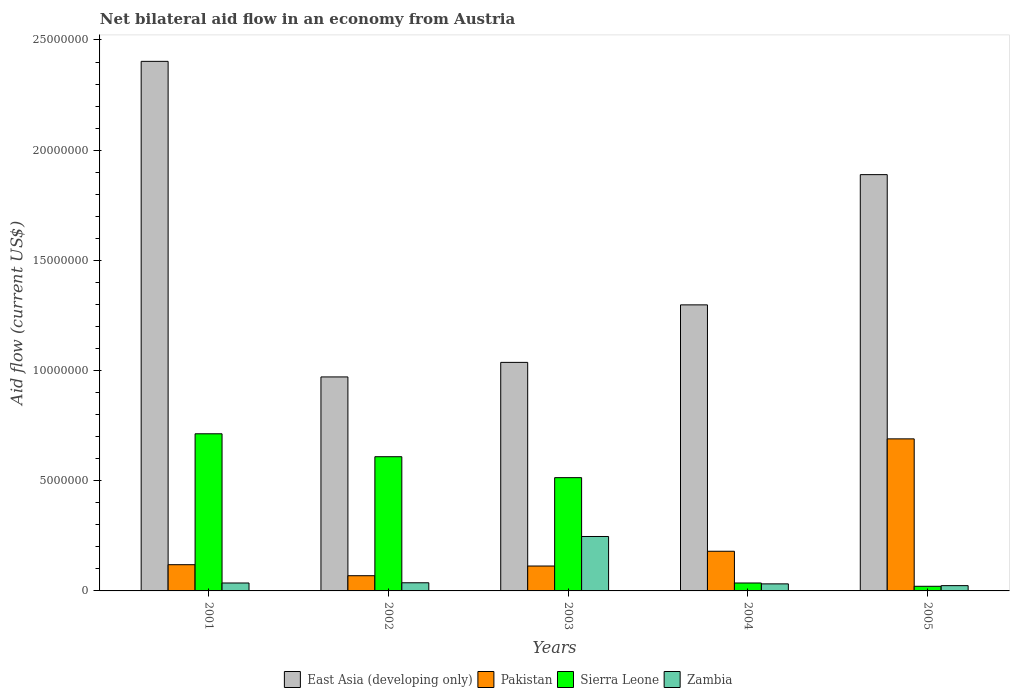How many different coloured bars are there?
Provide a short and direct response. 4. How many groups of bars are there?
Give a very brief answer. 5. Are the number of bars per tick equal to the number of legend labels?
Your answer should be compact. Yes. What is the label of the 5th group of bars from the left?
Ensure brevity in your answer.  2005. What is the net bilateral aid flow in Sierra Leone in 2004?
Make the answer very short. 3.60e+05. Across all years, what is the maximum net bilateral aid flow in East Asia (developing only)?
Keep it short and to the point. 2.40e+07. Across all years, what is the minimum net bilateral aid flow in Pakistan?
Provide a succinct answer. 6.90e+05. What is the total net bilateral aid flow in Pakistan in the graph?
Keep it short and to the point. 1.17e+07. What is the difference between the net bilateral aid flow in Zambia in 2004 and that in 2005?
Offer a very short reply. 8.00e+04. What is the difference between the net bilateral aid flow in Zambia in 2005 and the net bilateral aid flow in East Asia (developing only) in 2001?
Make the answer very short. -2.38e+07. What is the average net bilateral aid flow in Pakistan per year?
Ensure brevity in your answer.  2.34e+06. In the year 2004, what is the difference between the net bilateral aid flow in Sierra Leone and net bilateral aid flow in Zambia?
Offer a very short reply. 4.00e+04. In how many years, is the net bilateral aid flow in Sierra Leone greater than 9000000 US$?
Your answer should be very brief. 0. What is the ratio of the net bilateral aid flow in East Asia (developing only) in 2001 to that in 2005?
Give a very brief answer. 1.27. Is the difference between the net bilateral aid flow in Sierra Leone in 2004 and 2005 greater than the difference between the net bilateral aid flow in Zambia in 2004 and 2005?
Offer a terse response. Yes. What is the difference between the highest and the second highest net bilateral aid flow in Pakistan?
Your answer should be very brief. 5.10e+06. What is the difference between the highest and the lowest net bilateral aid flow in East Asia (developing only)?
Ensure brevity in your answer.  1.43e+07. In how many years, is the net bilateral aid flow in Zambia greater than the average net bilateral aid flow in Zambia taken over all years?
Your answer should be very brief. 1. Is the sum of the net bilateral aid flow in Pakistan in 2002 and 2003 greater than the maximum net bilateral aid flow in Zambia across all years?
Provide a short and direct response. No. What does the 3rd bar from the left in 2005 represents?
Make the answer very short. Sierra Leone. What does the 4th bar from the right in 2002 represents?
Ensure brevity in your answer.  East Asia (developing only). How many bars are there?
Your answer should be compact. 20. What is the difference between two consecutive major ticks on the Y-axis?
Ensure brevity in your answer.  5.00e+06. Does the graph contain grids?
Your answer should be compact. No. Where does the legend appear in the graph?
Give a very brief answer. Bottom center. How many legend labels are there?
Your answer should be very brief. 4. What is the title of the graph?
Provide a succinct answer. Net bilateral aid flow in an economy from Austria. What is the label or title of the Y-axis?
Your response must be concise. Aid flow (current US$). What is the Aid flow (current US$) of East Asia (developing only) in 2001?
Give a very brief answer. 2.40e+07. What is the Aid flow (current US$) of Pakistan in 2001?
Your answer should be compact. 1.19e+06. What is the Aid flow (current US$) in Sierra Leone in 2001?
Offer a terse response. 7.13e+06. What is the Aid flow (current US$) of Zambia in 2001?
Your answer should be compact. 3.60e+05. What is the Aid flow (current US$) of East Asia (developing only) in 2002?
Provide a succinct answer. 9.71e+06. What is the Aid flow (current US$) in Pakistan in 2002?
Give a very brief answer. 6.90e+05. What is the Aid flow (current US$) of Sierra Leone in 2002?
Offer a terse response. 6.09e+06. What is the Aid flow (current US$) of East Asia (developing only) in 2003?
Ensure brevity in your answer.  1.04e+07. What is the Aid flow (current US$) in Pakistan in 2003?
Your response must be concise. 1.13e+06. What is the Aid flow (current US$) in Sierra Leone in 2003?
Make the answer very short. 5.14e+06. What is the Aid flow (current US$) of Zambia in 2003?
Provide a short and direct response. 2.47e+06. What is the Aid flow (current US$) in East Asia (developing only) in 2004?
Your answer should be compact. 1.30e+07. What is the Aid flow (current US$) in Pakistan in 2004?
Make the answer very short. 1.80e+06. What is the Aid flow (current US$) in Sierra Leone in 2004?
Ensure brevity in your answer.  3.60e+05. What is the Aid flow (current US$) in Zambia in 2004?
Ensure brevity in your answer.  3.20e+05. What is the Aid flow (current US$) of East Asia (developing only) in 2005?
Give a very brief answer. 1.89e+07. What is the Aid flow (current US$) of Pakistan in 2005?
Make the answer very short. 6.90e+06. What is the Aid flow (current US$) of Zambia in 2005?
Offer a very short reply. 2.40e+05. Across all years, what is the maximum Aid flow (current US$) of East Asia (developing only)?
Offer a terse response. 2.40e+07. Across all years, what is the maximum Aid flow (current US$) in Pakistan?
Make the answer very short. 6.90e+06. Across all years, what is the maximum Aid flow (current US$) of Sierra Leone?
Offer a very short reply. 7.13e+06. Across all years, what is the maximum Aid flow (current US$) in Zambia?
Provide a short and direct response. 2.47e+06. Across all years, what is the minimum Aid flow (current US$) of East Asia (developing only)?
Ensure brevity in your answer.  9.71e+06. Across all years, what is the minimum Aid flow (current US$) in Pakistan?
Offer a terse response. 6.90e+05. Across all years, what is the minimum Aid flow (current US$) of Sierra Leone?
Ensure brevity in your answer.  2.10e+05. What is the total Aid flow (current US$) of East Asia (developing only) in the graph?
Ensure brevity in your answer.  7.60e+07. What is the total Aid flow (current US$) in Pakistan in the graph?
Offer a very short reply. 1.17e+07. What is the total Aid flow (current US$) in Sierra Leone in the graph?
Make the answer very short. 1.89e+07. What is the total Aid flow (current US$) of Zambia in the graph?
Your answer should be very brief. 3.76e+06. What is the difference between the Aid flow (current US$) of East Asia (developing only) in 2001 and that in 2002?
Your answer should be very brief. 1.43e+07. What is the difference between the Aid flow (current US$) in Sierra Leone in 2001 and that in 2002?
Offer a very short reply. 1.04e+06. What is the difference between the Aid flow (current US$) in East Asia (developing only) in 2001 and that in 2003?
Offer a terse response. 1.37e+07. What is the difference between the Aid flow (current US$) in Sierra Leone in 2001 and that in 2003?
Give a very brief answer. 1.99e+06. What is the difference between the Aid flow (current US$) of Zambia in 2001 and that in 2003?
Your answer should be very brief. -2.11e+06. What is the difference between the Aid flow (current US$) of East Asia (developing only) in 2001 and that in 2004?
Offer a terse response. 1.10e+07. What is the difference between the Aid flow (current US$) of Pakistan in 2001 and that in 2004?
Provide a short and direct response. -6.10e+05. What is the difference between the Aid flow (current US$) of Sierra Leone in 2001 and that in 2004?
Ensure brevity in your answer.  6.77e+06. What is the difference between the Aid flow (current US$) of East Asia (developing only) in 2001 and that in 2005?
Provide a short and direct response. 5.14e+06. What is the difference between the Aid flow (current US$) of Pakistan in 2001 and that in 2005?
Your answer should be very brief. -5.71e+06. What is the difference between the Aid flow (current US$) of Sierra Leone in 2001 and that in 2005?
Provide a succinct answer. 6.92e+06. What is the difference between the Aid flow (current US$) of East Asia (developing only) in 2002 and that in 2003?
Ensure brevity in your answer.  -6.60e+05. What is the difference between the Aid flow (current US$) of Pakistan in 2002 and that in 2003?
Your answer should be compact. -4.40e+05. What is the difference between the Aid flow (current US$) in Sierra Leone in 2002 and that in 2003?
Your answer should be very brief. 9.50e+05. What is the difference between the Aid flow (current US$) in Zambia in 2002 and that in 2003?
Provide a succinct answer. -2.10e+06. What is the difference between the Aid flow (current US$) of East Asia (developing only) in 2002 and that in 2004?
Your response must be concise. -3.27e+06. What is the difference between the Aid flow (current US$) in Pakistan in 2002 and that in 2004?
Offer a terse response. -1.11e+06. What is the difference between the Aid flow (current US$) of Sierra Leone in 2002 and that in 2004?
Ensure brevity in your answer.  5.73e+06. What is the difference between the Aid flow (current US$) in Zambia in 2002 and that in 2004?
Offer a very short reply. 5.00e+04. What is the difference between the Aid flow (current US$) of East Asia (developing only) in 2002 and that in 2005?
Offer a very short reply. -9.18e+06. What is the difference between the Aid flow (current US$) of Pakistan in 2002 and that in 2005?
Your answer should be compact. -6.21e+06. What is the difference between the Aid flow (current US$) of Sierra Leone in 2002 and that in 2005?
Your answer should be very brief. 5.88e+06. What is the difference between the Aid flow (current US$) in Zambia in 2002 and that in 2005?
Provide a succinct answer. 1.30e+05. What is the difference between the Aid flow (current US$) of East Asia (developing only) in 2003 and that in 2004?
Your response must be concise. -2.61e+06. What is the difference between the Aid flow (current US$) in Pakistan in 2003 and that in 2004?
Your answer should be compact. -6.70e+05. What is the difference between the Aid flow (current US$) of Sierra Leone in 2003 and that in 2004?
Your answer should be compact. 4.78e+06. What is the difference between the Aid flow (current US$) of Zambia in 2003 and that in 2004?
Keep it short and to the point. 2.15e+06. What is the difference between the Aid flow (current US$) of East Asia (developing only) in 2003 and that in 2005?
Offer a terse response. -8.52e+06. What is the difference between the Aid flow (current US$) of Pakistan in 2003 and that in 2005?
Ensure brevity in your answer.  -5.77e+06. What is the difference between the Aid flow (current US$) of Sierra Leone in 2003 and that in 2005?
Give a very brief answer. 4.93e+06. What is the difference between the Aid flow (current US$) in Zambia in 2003 and that in 2005?
Provide a succinct answer. 2.23e+06. What is the difference between the Aid flow (current US$) in East Asia (developing only) in 2004 and that in 2005?
Offer a terse response. -5.91e+06. What is the difference between the Aid flow (current US$) in Pakistan in 2004 and that in 2005?
Provide a succinct answer. -5.10e+06. What is the difference between the Aid flow (current US$) of Sierra Leone in 2004 and that in 2005?
Your answer should be very brief. 1.50e+05. What is the difference between the Aid flow (current US$) in East Asia (developing only) in 2001 and the Aid flow (current US$) in Pakistan in 2002?
Your answer should be compact. 2.33e+07. What is the difference between the Aid flow (current US$) of East Asia (developing only) in 2001 and the Aid flow (current US$) of Sierra Leone in 2002?
Your answer should be very brief. 1.79e+07. What is the difference between the Aid flow (current US$) of East Asia (developing only) in 2001 and the Aid flow (current US$) of Zambia in 2002?
Your answer should be very brief. 2.37e+07. What is the difference between the Aid flow (current US$) in Pakistan in 2001 and the Aid flow (current US$) in Sierra Leone in 2002?
Keep it short and to the point. -4.90e+06. What is the difference between the Aid flow (current US$) in Pakistan in 2001 and the Aid flow (current US$) in Zambia in 2002?
Make the answer very short. 8.20e+05. What is the difference between the Aid flow (current US$) in Sierra Leone in 2001 and the Aid flow (current US$) in Zambia in 2002?
Your response must be concise. 6.76e+06. What is the difference between the Aid flow (current US$) of East Asia (developing only) in 2001 and the Aid flow (current US$) of Pakistan in 2003?
Ensure brevity in your answer.  2.29e+07. What is the difference between the Aid flow (current US$) of East Asia (developing only) in 2001 and the Aid flow (current US$) of Sierra Leone in 2003?
Provide a short and direct response. 1.89e+07. What is the difference between the Aid flow (current US$) of East Asia (developing only) in 2001 and the Aid flow (current US$) of Zambia in 2003?
Make the answer very short. 2.16e+07. What is the difference between the Aid flow (current US$) of Pakistan in 2001 and the Aid flow (current US$) of Sierra Leone in 2003?
Offer a terse response. -3.95e+06. What is the difference between the Aid flow (current US$) of Pakistan in 2001 and the Aid flow (current US$) of Zambia in 2003?
Keep it short and to the point. -1.28e+06. What is the difference between the Aid flow (current US$) in Sierra Leone in 2001 and the Aid flow (current US$) in Zambia in 2003?
Your answer should be compact. 4.66e+06. What is the difference between the Aid flow (current US$) of East Asia (developing only) in 2001 and the Aid flow (current US$) of Pakistan in 2004?
Offer a terse response. 2.22e+07. What is the difference between the Aid flow (current US$) in East Asia (developing only) in 2001 and the Aid flow (current US$) in Sierra Leone in 2004?
Offer a very short reply. 2.37e+07. What is the difference between the Aid flow (current US$) in East Asia (developing only) in 2001 and the Aid flow (current US$) in Zambia in 2004?
Give a very brief answer. 2.37e+07. What is the difference between the Aid flow (current US$) of Pakistan in 2001 and the Aid flow (current US$) of Sierra Leone in 2004?
Your answer should be very brief. 8.30e+05. What is the difference between the Aid flow (current US$) in Pakistan in 2001 and the Aid flow (current US$) in Zambia in 2004?
Provide a short and direct response. 8.70e+05. What is the difference between the Aid flow (current US$) in Sierra Leone in 2001 and the Aid flow (current US$) in Zambia in 2004?
Make the answer very short. 6.81e+06. What is the difference between the Aid flow (current US$) of East Asia (developing only) in 2001 and the Aid flow (current US$) of Pakistan in 2005?
Ensure brevity in your answer.  1.71e+07. What is the difference between the Aid flow (current US$) in East Asia (developing only) in 2001 and the Aid flow (current US$) in Sierra Leone in 2005?
Provide a succinct answer. 2.38e+07. What is the difference between the Aid flow (current US$) of East Asia (developing only) in 2001 and the Aid flow (current US$) of Zambia in 2005?
Your answer should be compact. 2.38e+07. What is the difference between the Aid flow (current US$) of Pakistan in 2001 and the Aid flow (current US$) of Sierra Leone in 2005?
Ensure brevity in your answer.  9.80e+05. What is the difference between the Aid flow (current US$) in Pakistan in 2001 and the Aid flow (current US$) in Zambia in 2005?
Offer a very short reply. 9.50e+05. What is the difference between the Aid flow (current US$) in Sierra Leone in 2001 and the Aid flow (current US$) in Zambia in 2005?
Your response must be concise. 6.89e+06. What is the difference between the Aid flow (current US$) of East Asia (developing only) in 2002 and the Aid flow (current US$) of Pakistan in 2003?
Ensure brevity in your answer.  8.58e+06. What is the difference between the Aid flow (current US$) in East Asia (developing only) in 2002 and the Aid flow (current US$) in Sierra Leone in 2003?
Provide a succinct answer. 4.57e+06. What is the difference between the Aid flow (current US$) in East Asia (developing only) in 2002 and the Aid flow (current US$) in Zambia in 2003?
Ensure brevity in your answer.  7.24e+06. What is the difference between the Aid flow (current US$) in Pakistan in 2002 and the Aid flow (current US$) in Sierra Leone in 2003?
Your answer should be very brief. -4.45e+06. What is the difference between the Aid flow (current US$) in Pakistan in 2002 and the Aid flow (current US$) in Zambia in 2003?
Provide a succinct answer. -1.78e+06. What is the difference between the Aid flow (current US$) of Sierra Leone in 2002 and the Aid flow (current US$) of Zambia in 2003?
Make the answer very short. 3.62e+06. What is the difference between the Aid flow (current US$) of East Asia (developing only) in 2002 and the Aid flow (current US$) of Pakistan in 2004?
Offer a very short reply. 7.91e+06. What is the difference between the Aid flow (current US$) of East Asia (developing only) in 2002 and the Aid flow (current US$) of Sierra Leone in 2004?
Offer a terse response. 9.35e+06. What is the difference between the Aid flow (current US$) of East Asia (developing only) in 2002 and the Aid flow (current US$) of Zambia in 2004?
Keep it short and to the point. 9.39e+06. What is the difference between the Aid flow (current US$) in Pakistan in 2002 and the Aid flow (current US$) in Sierra Leone in 2004?
Make the answer very short. 3.30e+05. What is the difference between the Aid flow (current US$) in Sierra Leone in 2002 and the Aid flow (current US$) in Zambia in 2004?
Your answer should be compact. 5.77e+06. What is the difference between the Aid flow (current US$) in East Asia (developing only) in 2002 and the Aid flow (current US$) in Pakistan in 2005?
Offer a terse response. 2.81e+06. What is the difference between the Aid flow (current US$) in East Asia (developing only) in 2002 and the Aid flow (current US$) in Sierra Leone in 2005?
Provide a short and direct response. 9.50e+06. What is the difference between the Aid flow (current US$) in East Asia (developing only) in 2002 and the Aid flow (current US$) in Zambia in 2005?
Provide a short and direct response. 9.47e+06. What is the difference between the Aid flow (current US$) in Pakistan in 2002 and the Aid flow (current US$) in Zambia in 2005?
Make the answer very short. 4.50e+05. What is the difference between the Aid flow (current US$) in Sierra Leone in 2002 and the Aid flow (current US$) in Zambia in 2005?
Your answer should be compact. 5.85e+06. What is the difference between the Aid flow (current US$) in East Asia (developing only) in 2003 and the Aid flow (current US$) in Pakistan in 2004?
Provide a short and direct response. 8.57e+06. What is the difference between the Aid flow (current US$) of East Asia (developing only) in 2003 and the Aid flow (current US$) of Sierra Leone in 2004?
Your response must be concise. 1.00e+07. What is the difference between the Aid flow (current US$) in East Asia (developing only) in 2003 and the Aid flow (current US$) in Zambia in 2004?
Provide a short and direct response. 1.00e+07. What is the difference between the Aid flow (current US$) of Pakistan in 2003 and the Aid flow (current US$) of Sierra Leone in 2004?
Give a very brief answer. 7.70e+05. What is the difference between the Aid flow (current US$) of Pakistan in 2003 and the Aid flow (current US$) of Zambia in 2004?
Your answer should be compact. 8.10e+05. What is the difference between the Aid flow (current US$) in Sierra Leone in 2003 and the Aid flow (current US$) in Zambia in 2004?
Ensure brevity in your answer.  4.82e+06. What is the difference between the Aid flow (current US$) in East Asia (developing only) in 2003 and the Aid flow (current US$) in Pakistan in 2005?
Give a very brief answer. 3.47e+06. What is the difference between the Aid flow (current US$) in East Asia (developing only) in 2003 and the Aid flow (current US$) in Sierra Leone in 2005?
Offer a very short reply. 1.02e+07. What is the difference between the Aid flow (current US$) in East Asia (developing only) in 2003 and the Aid flow (current US$) in Zambia in 2005?
Your answer should be very brief. 1.01e+07. What is the difference between the Aid flow (current US$) of Pakistan in 2003 and the Aid flow (current US$) of Sierra Leone in 2005?
Offer a terse response. 9.20e+05. What is the difference between the Aid flow (current US$) in Pakistan in 2003 and the Aid flow (current US$) in Zambia in 2005?
Make the answer very short. 8.90e+05. What is the difference between the Aid flow (current US$) in Sierra Leone in 2003 and the Aid flow (current US$) in Zambia in 2005?
Provide a succinct answer. 4.90e+06. What is the difference between the Aid flow (current US$) of East Asia (developing only) in 2004 and the Aid flow (current US$) of Pakistan in 2005?
Provide a short and direct response. 6.08e+06. What is the difference between the Aid flow (current US$) of East Asia (developing only) in 2004 and the Aid flow (current US$) of Sierra Leone in 2005?
Give a very brief answer. 1.28e+07. What is the difference between the Aid flow (current US$) of East Asia (developing only) in 2004 and the Aid flow (current US$) of Zambia in 2005?
Offer a terse response. 1.27e+07. What is the difference between the Aid flow (current US$) of Pakistan in 2004 and the Aid flow (current US$) of Sierra Leone in 2005?
Keep it short and to the point. 1.59e+06. What is the difference between the Aid flow (current US$) of Pakistan in 2004 and the Aid flow (current US$) of Zambia in 2005?
Your response must be concise. 1.56e+06. What is the average Aid flow (current US$) of East Asia (developing only) per year?
Make the answer very short. 1.52e+07. What is the average Aid flow (current US$) of Pakistan per year?
Provide a succinct answer. 2.34e+06. What is the average Aid flow (current US$) of Sierra Leone per year?
Provide a short and direct response. 3.79e+06. What is the average Aid flow (current US$) in Zambia per year?
Provide a short and direct response. 7.52e+05. In the year 2001, what is the difference between the Aid flow (current US$) of East Asia (developing only) and Aid flow (current US$) of Pakistan?
Keep it short and to the point. 2.28e+07. In the year 2001, what is the difference between the Aid flow (current US$) of East Asia (developing only) and Aid flow (current US$) of Sierra Leone?
Provide a short and direct response. 1.69e+07. In the year 2001, what is the difference between the Aid flow (current US$) in East Asia (developing only) and Aid flow (current US$) in Zambia?
Provide a succinct answer. 2.37e+07. In the year 2001, what is the difference between the Aid flow (current US$) of Pakistan and Aid flow (current US$) of Sierra Leone?
Your answer should be very brief. -5.94e+06. In the year 2001, what is the difference between the Aid flow (current US$) of Pakistan and Aid flow (current US$) of Zambia?
Ensure brevity in your answer.  8.30e+05. In the year 2001, what is the difference between the Aid flow (current US$) of Sierra Leone and Aid flow (current US$) of Zambia?
Your answer should be very brief. 6.77e+06. In the year 2002, what is the difference between the Aid flow (current US$) of East Asia (developing only) and Aid flow (current US$) of Pakistan?
Keep it short and to the point. 9.02e+06. In the year 2002, what is the difference between the Aid flow (current US$) of East Asia (developing only) and Aid flow (current US$) of Sierra Leone?
Provide a short and direct response. 3.62e+06. In the year 2002, what is the difference between the Aid flow (current US$) in East Asia (developing only) and Aid flow (current US$) in Zambia?
Offer a very short reply. 9.34e+06. In the year 2002, what is the difference between the Aid flow (current US$) in Pakistan and Aid flow (current US$) in Sierra Leone?
Offer a terse response. -5.40e+06. In the year 2002, what is the difference between the Aid flow (current US$) of Pakistan and Aid flow (current US$) of Zambia?
Your response must be concise. 3.20e+05. In the year 2002, what is the difference between the Aid flow (current US$) of Sierra Leone and Aid flow (current US$) of Zambia?
Offer a terse response. 5.72e+06. In the year 2003, what is the difference between the Aid flow (current US$) in East Asia (developing only) and Aid flow (current US$) in Pakistan?
Your response must be concise. 9.24e+06. In the year 2003, what is the difference between the Aid flow (current US$) in East Asia (developing only) and Aid flow (current US$) in Sierra Leone?
Your answer should be compact. 5.23e+06. In the year 2003, what is the difference between the Aid flow (current US$) in East Asia (developing only) and Aid flow (current US$) in Zambia?
Make the answer very short. 7.90e+06. In the year 2003, what is the difference between the Aid flow (current US$) of Pakistan and Aid flow (current US$) of Sierra Leone?
Your answer should be compact. -4.01e+06. In the year 2003, what is the difference between the Aid flow (current US$) of Pakistan and Aid flow (current US$) of Zambia?
Keep it short and to the point. -1.34e+06. In the year 2003, what is the difference between the Aid flow (current US$) of Sierra Leone and Aid flow (current US$) of Zambia?
Your response must be concise. 2.67e+06. In the year 2004, what is the difference between the Aid flow (current US$) of East Asia (developing only) and Aid flow (current US$) of Pakistan?
Keep it short and to the point. 1.12e+07. In the year 2004, what is the difference between the Aid flow (current US$) of East Asia (developing only) and Aid flow (current US$) of Sierra Leone?
Provide a short and direct response. 1.26e+07. In the year 2004, what is the difference between the Aid flow (current US$) in East Asia (developing only) and Aid flow (current US$) in Zambia?
Keep it short and to the point. 1.27e+07. In the year 2004, what is the difference between the Aid flow (current US$) of Pakistan and Aid flow (current US$) of Sierra Leone?
Your answer should be compact. 1.44e+06. In the year 2004, what is the difference between the Aid flow (current US$) in Pakistan and Aid flow (current US$) in Zambia?
Provide a short and direct response. 1.48e+06. In the year 2005, what is the difference between the Aid flow (current US$) in East Asia (developing only) and Aid flow (current US$) in Pakistan?
Make the answer very short. 1.20e+07. In the year 2005, what is the difference between the Aid flow (current US$) of East Asia (developing only) and Aid flow (current US$) of Sierra Leone?
Your answer should be compact. 1.87e+07. In the year 2005, what is the difference between the Aid flow (current US$) in East Asia (developing only) and Aid flow (current US$) in Zambia?
Give a very brief answer. 1.86e+07. In the year 2005, what is the difference between the Aid flow (current US$) of Pakistan and Aid flow (current US$) of Sierra Leone?
Ensure brevity in your answer.  6.69e+06. In the year 2005, what is the difference between the Aid flow (current US$) in Pakistan and Aid flow (current US$) in Zambia?
Offer a very short reply. 6.66e+06. In the year 2005, what is the difference between the Aid flow (current US$) in Sierra Leone and Aid flow (current US$) in Zambia?
Offer a terse response. -3.00e+04. What is the ratio of the Aid flow (current US$) in East Asia (developing only) in 2001 to that in 2002?
Keep it short and to the point. 2.47. What is the ratio of the Aid flow (current US$) of Pakistan in 2001 to that in 2002?
Offer a very short reply. 1.72. What is the ratio of the Aid flow (current US$) in Sierra Leone in 2001 to that in 2002?
Provide a succinct answer. 1.17. What is the ratio of the Aid flow (current US$) in Zambia in 2001 to that in 2002?
Make the answer very short. 0.97. What is the ratio of the Aid flow (current US$) in East Asia (developing only) in 2001 to that in 2003?
Keep it short and to the point. 2.32. What is the ratio of the Aid flow (current US$) in Pakistan in 2001 to that in 2003?
Ensure brevity in your answer.  1.05. What is the ratio of the Aid flow (current US$) in Sierra Leone in 2001 to that in 2003?
Keep it short and to the point. 1.39. What is the ratio of the Aid flow (current US$) of Zambia in 2001 to that in 2003?
Offer a terse response. 0.15. What is the ratio of the Aid flow (current US$) in East Asia (developing only) in 2001 to that in 2004?
Your answer should be compact. 1.85. What is the ratio of the Aid flow (current US$) in Pakistan in 2001 to that in 2004?
Keep it short and to the point. 0.66. What is the ratio of the Aid flow (current US$) of Sierra Leone in 2001 to that in 2004?
Your answer should be very brief. 19.81. What is the ratio of the Aid flow (current US$) in East Asia (developing only) in 2001 to that in 2005?
Keep it short and to the point. 1.27. What is the ratio of the Aid flow (current US$) in Pakistan in 2001 to that in 2005?
Your answer should be compact. 0.17. What is the ratio of the Aid flow (current US$) of Sierra Leone in 2001 to that in 2005?
Offer a terse response. 33.95. What is the ratio of the Aid flow (current US$) in Zambia in 2001 to that in 2005?
Give a very brief answer. 1.5. What is the ratio of the Aid flow (current US$) of East Asia (developing only) in 2002 to that in 2003?
Offer a terse response. 0.94. What is the ratio of the Aid flow (current US$) in Pakistan in 2002 to that in 2003?
Your answer should be compact. 0.61. What is the ratio of the Aid flow (current US$) of Sierra Leone in 2002 to that in 2003?
Keep it short and to the point. 1.18. What is the ratio of the Aid flow (current US$) of Zambia in 2002 to that in 2003?
Your response must be concise. 0.15. What is the ratio of the Aid flow (current US$) in East Asia (developing only) in 2002 to that in 2004?
Keep it short and to the point. 0.75. What is the ratio of the Aid flow (current US$) in Pakistan in 2002 to that in 2004?
Your answer should be very brief. 0.38. What is the ratio of the Aid flow (current US$) of Sierra Leone in 2002 to that in 2004?
Keep it short and to the point. 16.92. What is the ratio of the Aid flow (current US$) in Zambia in 2002 to that in 2004?
Give a very brief answer. 1.16. What is the ratio of the Aid flow (current US$) of East Asia (developing only) in 2002 to that in 2005?
Your answer should be very brief. 0.51. What is the ratio of the Aid flow (current US$) of Pakistan in 2002 to that in 2005?
Provide a succinct answer. 0.1. What is the ratio of the Aid flow (current US$) of Zambia in 2002 to that in 2005?
Give a very brief answer. 1.54. What is the ratio of the Aid flow (current US$) in East Asia (developing only) in 2003 to that in 2004?
Offer a very short reply. 0.8. What is the ratio of the Aid flow (current US$) in Pakistan in 2003 to that in 2004?
Provide a succinct answer. 0.63. What is the ratio of the Aid flow (current US$) in Sierra Leone in 2003 to that in 2004?
Ensure brevity in your answer.  14.28. What is the ratio of the Aid flow (current US$) in Zambia in 2003 to that in 2004?
Provide a succinct answer. 7.72. What is the ratio of the Aid flow (current US$) in East Asia (developing only) in 2003 to that in 2005?
Your response must be concise. 0.55. What is the ratio of the Aid flow (current US$) of Pakistan in 2003 to that in 2005?
Provide a short and direct response. 0.16. What is the ratio of the Aid flow (current US$) of Sierra Leone in 2003 to that in 2005?
Offer a terse response. 24.48. What is the ratio of the Aid flow (current US$) in Zambia in 2003 to that in 2005?
Provide a short and direct response. 10.29. What is the ratio of the Aid flow (current US$) in East Asia (developing only) in 2004 to that in 2005?
Provide a succinct answer. 0.69. What is the ratio of the Aid flow (current US$) in Pakistan in 2004 to that in 2005?
Provide a short and direct response. 0.26. What is the ratio of the Aid flow (current US$) in Sierra Leone in 2004 to that in 2005?
Provide a succinct answer. 1.71. What is the ratio of the Aid flow (current US$) of Zambia in 2004 to that in 2005?
Provide a short and direct response. 1.33. What is the difference between the highest and the second highest Aid flow (current US$) of East Asia (developing only)?
Provide a short and direct response. 5.14e+06. What is the difference between the highest and the second highest Aid flow (current US$) in Pakistan?
Your response must be concise. 5.10e+06. What is the difference between the highest and the second highest Aid flow (current US$) in Sierra Leone?
Ensure brevity in your answer.  1.04e+06. What is the difference between the highest and the second highest Aid flow (current US$) of Zambia?
Provide a short and direct response. 2.10e+06. What is the difference between the highest and the lowest Aid flow (current US$) in East Asia (developing only)?
Make the answer very short. 1.43e+07. What is the difference between the highest and the lowest Aid flow (current US$) of Pakistan?
Provide a short and direct response. 6.21e+06. What is the difference between the highest and the lowest Aid flow (current US$) in Sierra Leone?
Ensure brevity in your answer.  6.92e+06. What is the difference between the highest and the lowest Aid flow (current US$) of Zambia?
Provide a short and direct response. 2.23e+06. 